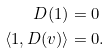Convert formula to latex. <formula><loc_0><loc_0><loc_500><loc_500>D ( 1 ) & = 0 \\ \langle 1 , D ( v ) \rangle & = 0 .</formula> 